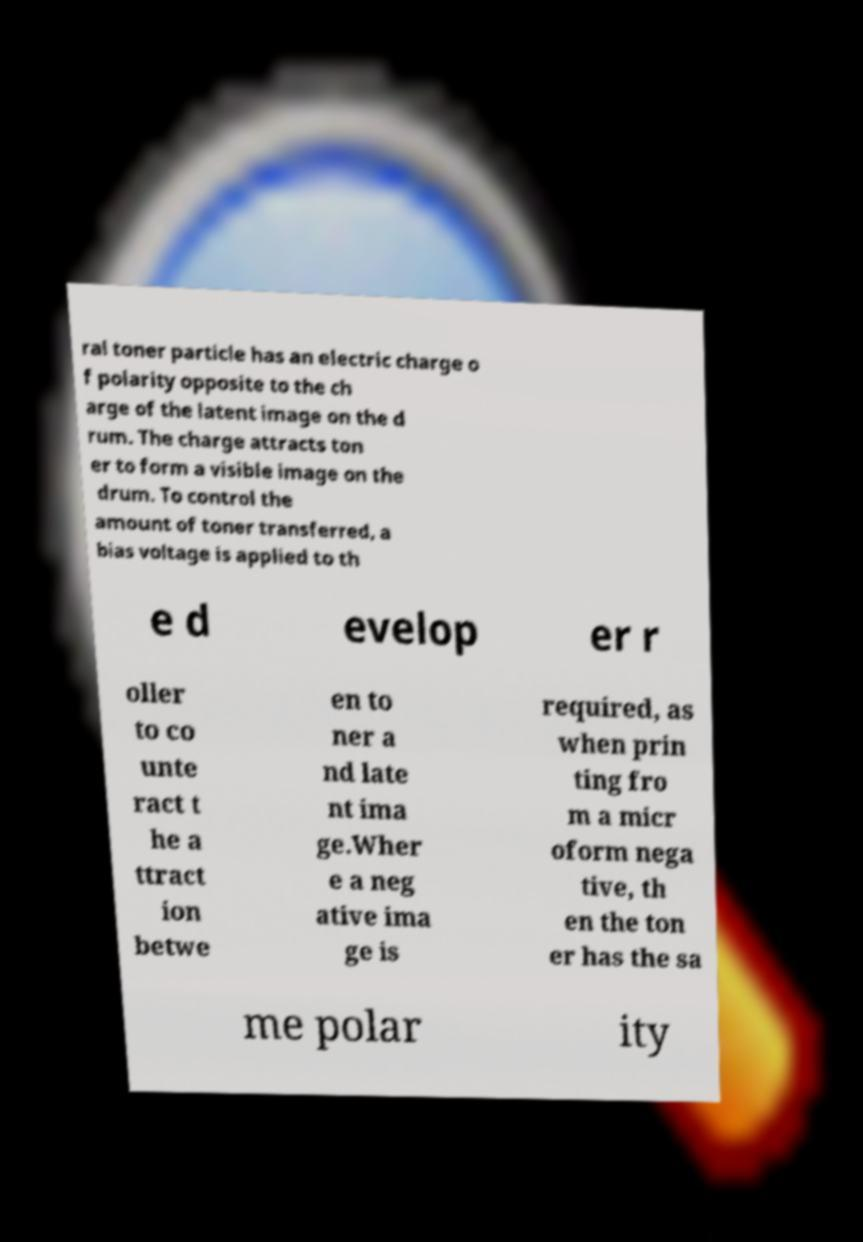Please read and relay the text visible in this image. What does it say? ral toner particle has an electric charge o f polarity opposite to the ch arge of the latent image on the d rum. The charge attracts ton er to form a visible image on the drum. To control the amount of toner transferred, a bias voltage is applied to th e d evelop er r oller to co unte ract t he a ttract ion betwe en to ner a nd late nt ima ge.Wher e a neg ative ima ge is required, as when prin ting fro m a micr oform nega tive, th en the ton er has the sa me polar ity 